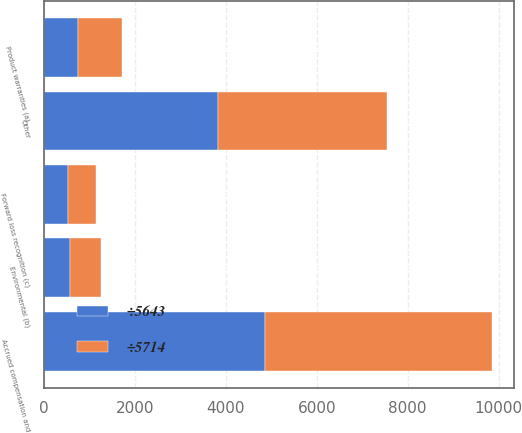<chart> <loc_0><loc_0><loc_500><loc_500><stacked_bar_chart><ecel><fcel>Accrued compensation and<fcel>Product warranties (a)<fcel>Environmental (b)<fcel>Forward loss recognition (c)<fcel>Other<nl><fcel>÷5714<fcel>4996<fcel>962<fcel>679<fcel>607<fcel>3718<nl><fcel>÷5643<fcel>4852<fcel>761<fcel>582<fcel>532<fcel>3831<nl></chart> 